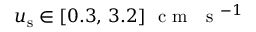Convert formula to latex. <formula><loc_0><loc_0><loc_500><loc_500>u _ { s } \in [ 0 . 3 , \, 3 . 2 ] c m s ^ { - 1 }</formula> 